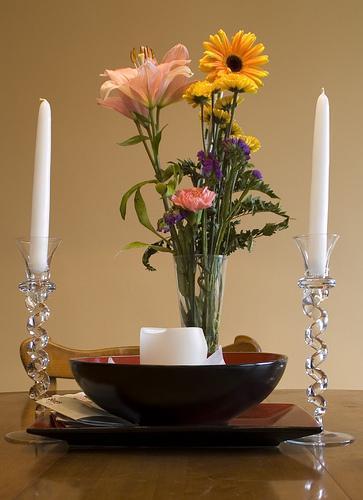How many long candles are on the table?
Give a very brief answer. 2. How many chairs are pictured?
Give a very brief answer. 1. 